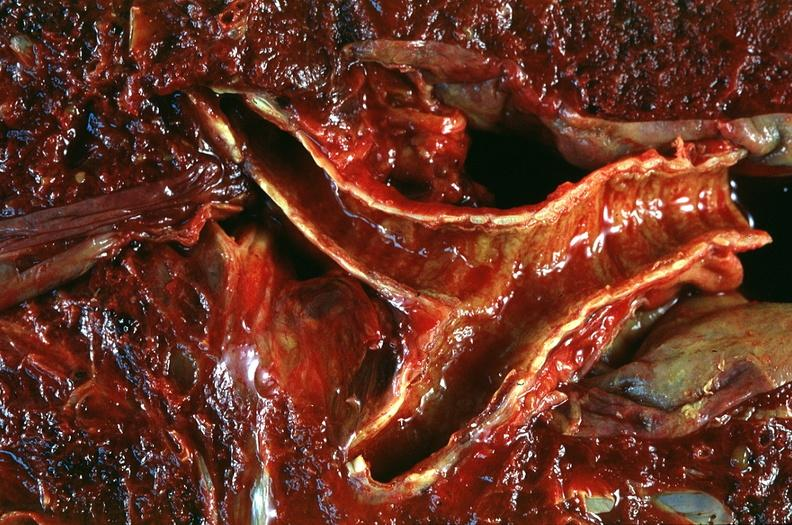does stress show lung, emphysema and bronchial hemorrhage, alpha-1 antitrypsin deficiency?
Answer the question using a single word or phrase. No 